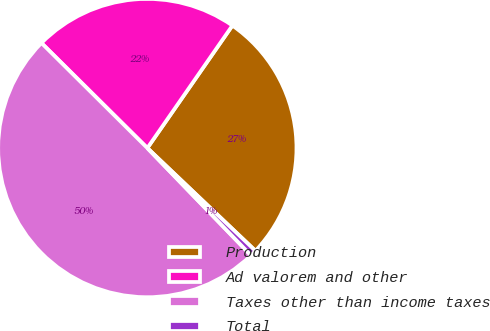<chart> <loc_0><loc_0><loc_500><loc_500><pie_chart><fcel>Production<fcel>Ad valorem and other<fcel>Taxes other than income taxes<fcel>Total<nl><fcel>27.44%<fcel>22.22%<fcel>49.66%<fcel>0.68%<nl></chart> 